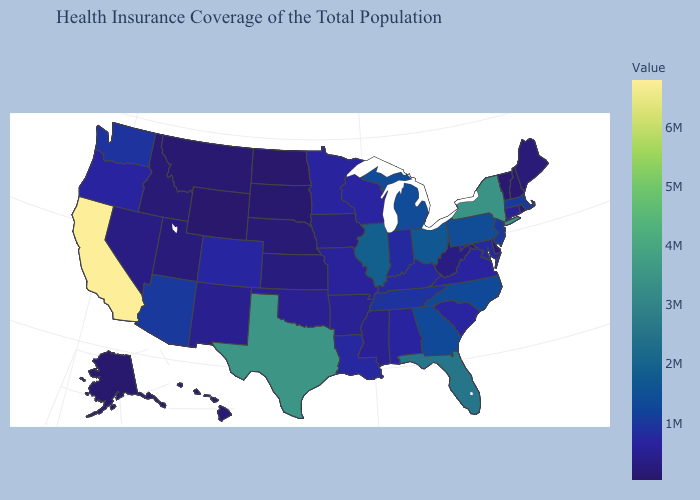Does the map have missing data?
Keep it brief. No. Which states have the highest value in the USA?
Answer briefly. California. Does New York have the highest value in the Northeast?
Write a very short answer. Yes. Does the map have missing data?
Quick response, please. No. Among the states that border Nebraska , does Kansas have the highest value?
Short answer required. No. Does South Carolina have the lowest value in the South?
Keep it brief. No. Which states have the lowest value in the West?
Be succinct. Wyoming. 